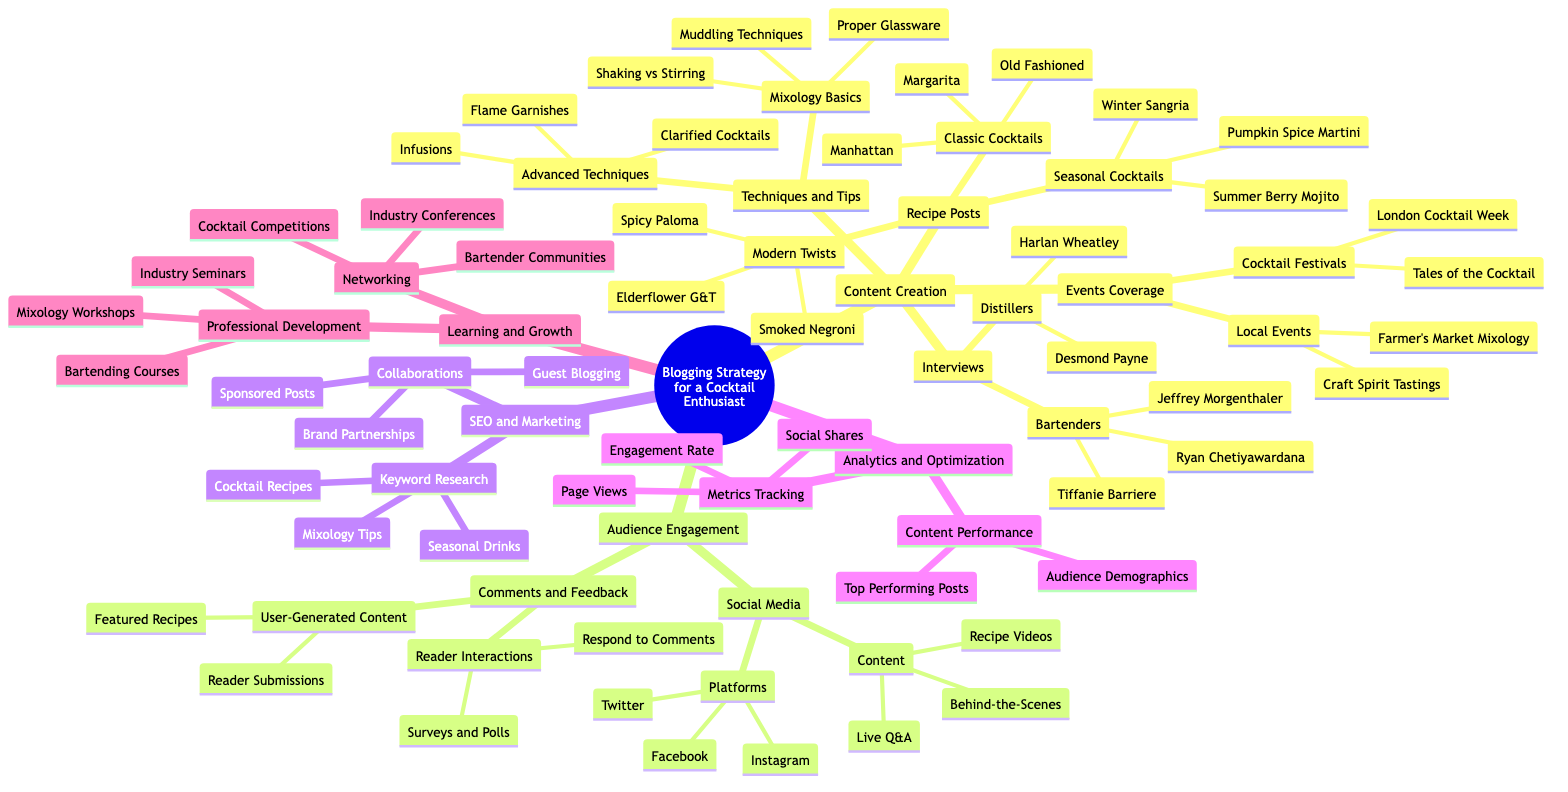What are the three types of Recipe Posts? The diagram lists three types of Recipe Posts under Content Creation: Classic Cocktails, Modern Twists, and Seasonal Cocktails.
Answer: Classic Cocktails, Modern Twists, Seasonal Cocktails Who is one of the bartenders interviewed? The Bartenders section of Interviews includes Tiffanie Barriere, Ryan Chetiyawardana, and Jeffrey Morgenthaler. Since the question asks for one, we can simply pick Tiffanie Barriere.
Answer: Tiffanie Barriere What is one of the social media platforms listed? The Platforms section under Audience Engagement lists Instagram, Twitter, and Facebook. Any of these could be a valid answer, but we can choose Instagram.
Answer: Instagram How many types of Audience Engagement content are there? The Audience Engagement section includes Two main nodes: Social Media and Comments and Feedback. This results in a total of two types.
Answer: 2 What is included in Learning and Growth's Professional Development? The Professional Development section under Learning and Growth contains Bartending Courses, Mixology Workshops, and Industry Seminars. Therefore, any one of these could serve as a direct answer.
Answer: Bartending Courses Which cocktail festival is mentioned? The Cocktail Festivals sub-category under Events Coverage lists Tales of the Cocktail and London Cocktail Week. Either of these can serve as an answer, but we'll choose Tales of the Cocktail.
Answer: Tales of the Cocktail What is being tracked in the Metrics Tracking category? One of the metrics tracked in the Metrics Tracking section is Page Views, Engagement Rate, and Social Shares. Any of these could be chosen, and we'll select Page Views for this response.
Answer: Page Views What are the techniques in Mixology Basics? Mixology Basics includes Shaking vs Stirring, Muddling Techniques, and Proper Glassware. Any of these could be mentioned, but we'll say Shaking vs Stirring.
Answer: Shaking vs Stirring How many interviews are there with Distillers? The Interviews section lists two individuals: Desmond Payne and Harlan Wheatley, resulting in a total of two Distillers.
Answer: 2 